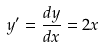Convert formula to latex. <formula><loc_0><loc_0><loc_500><loc_500>y ^ { \prime } = \frac { d y } { d x } = 2 x</formula> 